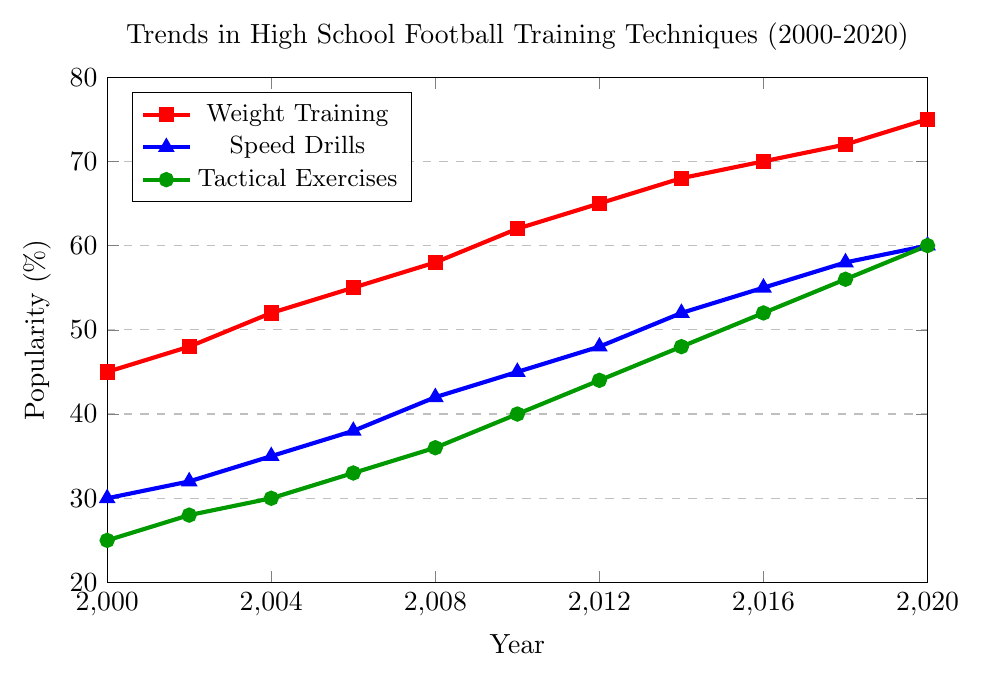What was the most popular training technique in 2020? In 2020, the plot shows Weight Training at 75%, Speed Drills at 60%, and Tactical Exercises also at 60%. Weight Training is the most popular.
Answer: Weight Training By how much did the popularity of Speed Drills increase from 2000 to 2010? In 2000, Speed Drills were at 30%, and by 2010, they had risen to 45%. The increase is 45% - 30% = 15%.
Answer: 15% During which year did Tactical Exercises reach the 50% popularity mark? The plot shows Tactical Exercises reaching 50% between 2014 and 2016. By inspection, it's clear the value during one of these years is 52%, making 2016 the year they passed 50%.
Answer: 2016 What is the difference in popularity between Weight Training and Tactical Exercises in 2012? In 2012, the plot shows Weight Training at 65% and Tactical Exercises at 44%. The difference is 65% - 44% = 21%.
Answer: 21% Which training technique saw the highest increase in popularity from 2000 to 2020? Calculating the difference, Weight Training went from 45% to 75% (an increase of 30%), Speed Drills from 30% to 60% (an increase of 30%), and Tactical Exercises from 25% to 60% (an increase of 35%). Tactical Exercises had the highest increase.
Answer: Tactical Exercises On average, how much did the popularity of Speed Drills increase every two years from 2000 to 2020? From 2000 to 2020 is 20 years, divided into ten 2-year periods. Speed Drills went from 30% to 60%, an increase of 30%. Average increase per 2 years is 30% / 10 = 3%.
Answer: 3% In which periods did Weight Training and Speed Drills gain exactly the same amount of popularity? Inspection shows that both Weight Training and Speed Drills increased by 7% each period: 2008-2010 (Weight: 58% to 62%, Speed: 42% to 45%) and 2018-2020 (Weight: 72% to 75%, Speed: 58% to 60%). Both periods show equal increases.
Answer: 2008-2010 and 2018-2020 Which two techniques reached exactly 48% popularity in the same year? In 2014, both Speed Drills and Tactical Exercises reached 48%, as shown in the plot.
Answer: Speed Drills and Tactical Exercises 